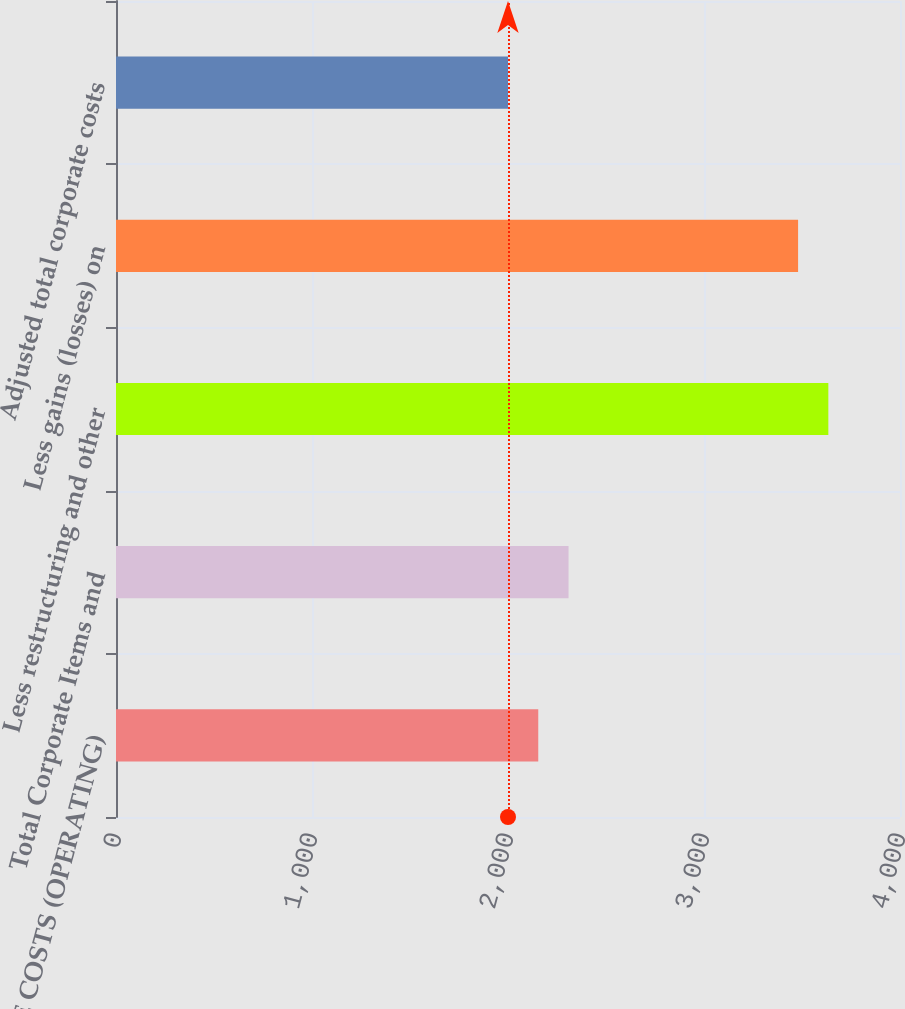<chart> <loc_0><loc_0><loc_500><loc_500><bar_chart><fcel>CORPORATE COSTS (OPERATING)<fcel>Total Corporate Items and<fcel>Less restructuring and other<fcel>Less gains (losses) on<fcel>Adjusted total corporate costs<nl><fcel>2154.4<fcel>2308.8<fcel>3634.4<fcel>3480<fcel>2000<nl></chart> 